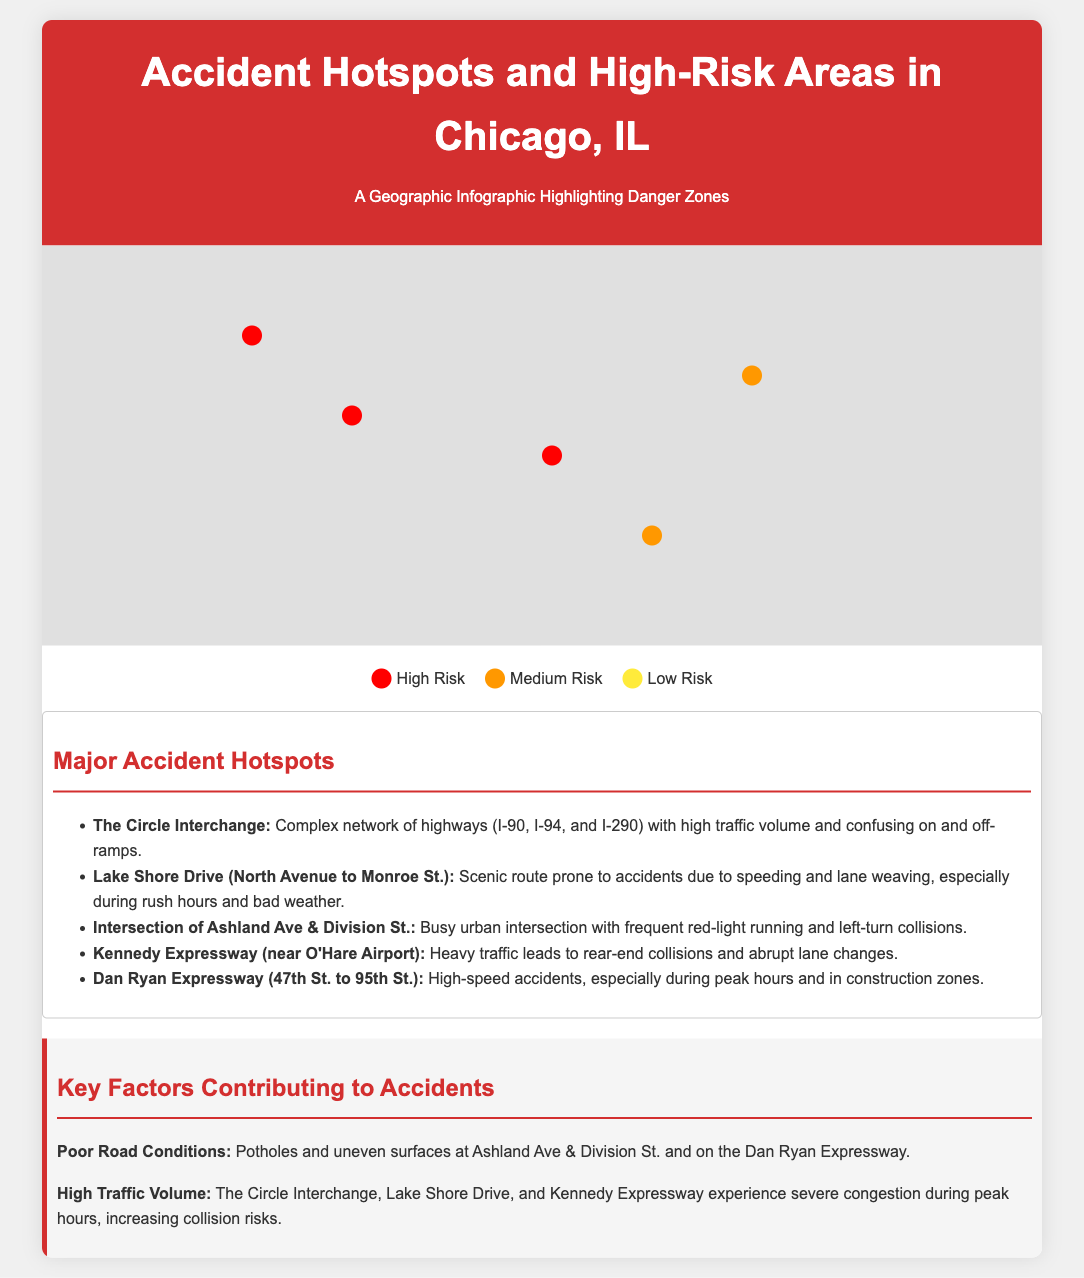What is the title of the infographic? The title is prominently displayed at the top of the document, indicating the focus of the graphic.
Answer: Accident Hotspots and High-Risk Areas in Chicago, IL How many major accident hotspots are listed? The list under "Major Accident Hotspots" contains five different locations, each noted for their frequency of accidents.
Answer: Five What color represents High Risk areas on the map? The legend in the infographic indicates that the color red is used to denote High Risk areas.
Answer: Red Which area has a description involving complex highways? The information provided describes a particular area noted for its complex network and high traffic.
Answer: The Circle Interchange What common cause is mentioned for accidents on Lake Shore Drive? The annotations recommend a specific behavior that contributes to accidents on this scenic route.
Answer: Speeding What is a noted cause of accidents at Ashland Ave & Division St.? The document mentions a specific behavior related to traffic violations that causes accidents at this intersection.
Answer: Red-light running During which time is the Kennedy Expressway noted for rear-end collisions? The document implies that certain times of day are particularly dangerous for accidents on this expressway due to heavy traffic.
Answer: Peak hours What two highways are connected to The Circle Interchange? The information box mentions specific highways that contribute to the complexity of this area.
Answer: I-90 and I-94 What key factor contributes to accidents on the Dan Ryan Expressway? The annotations detail a specific situation that leads to increased accident frequency in this area.
Answer: High-speed accidents 